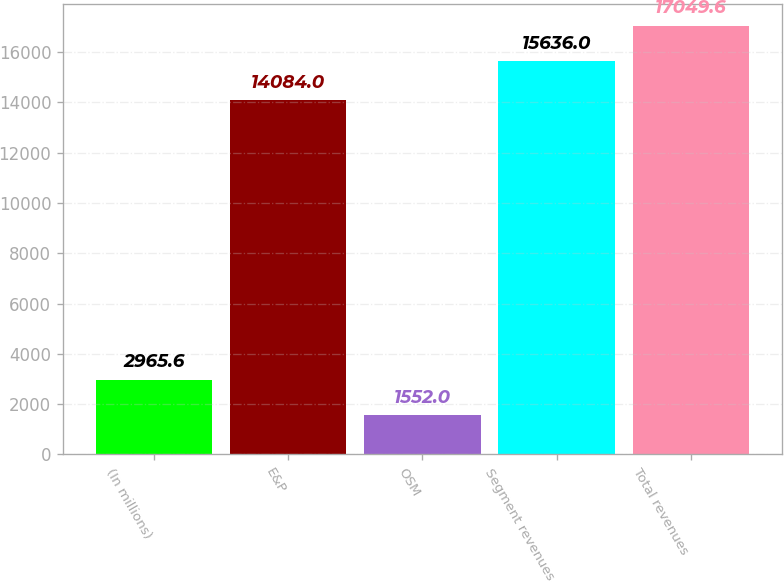<chart> <loc_0><loc_0><loc_500><loc_500><bar_chart><fcel>(In millions)<fcel>E&P<fcel>OSM<fcel>Segment revenues<fcel>Total revenues<nl><fcel>2965.6<fcel>14084<fcel>1552<fcel>15636<fcel>17049.6<nl></chart> 